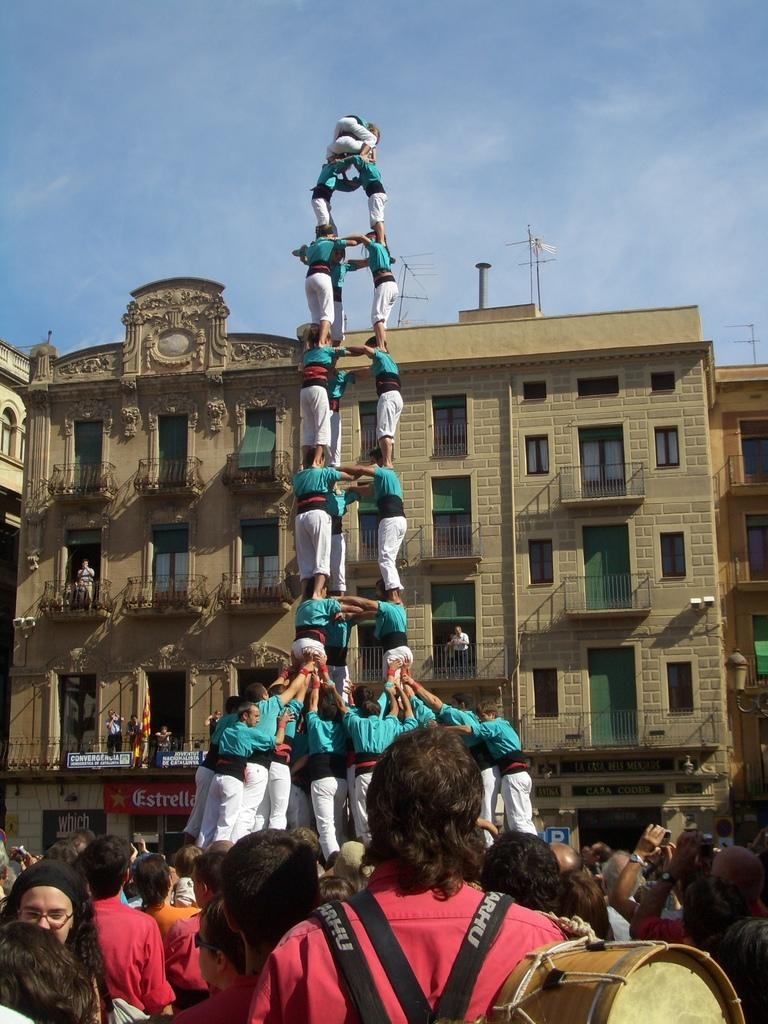What can be seen at the bottom of the image? There is a group of persons standing at the bottom of the image. What is visible in the background of the image? There is a building in the background of the image. How would you describe the sky in the image? The sky is cloudy at the top of the image. What type of apparel is the carriage wearing in the image? There is no carriage present in the image, so it is not possible to determine what type of apparel it might be wearing. How many bites can be seen being taken out of the building in the image? There are no bites present in the image; it features a group of persons and a building. 